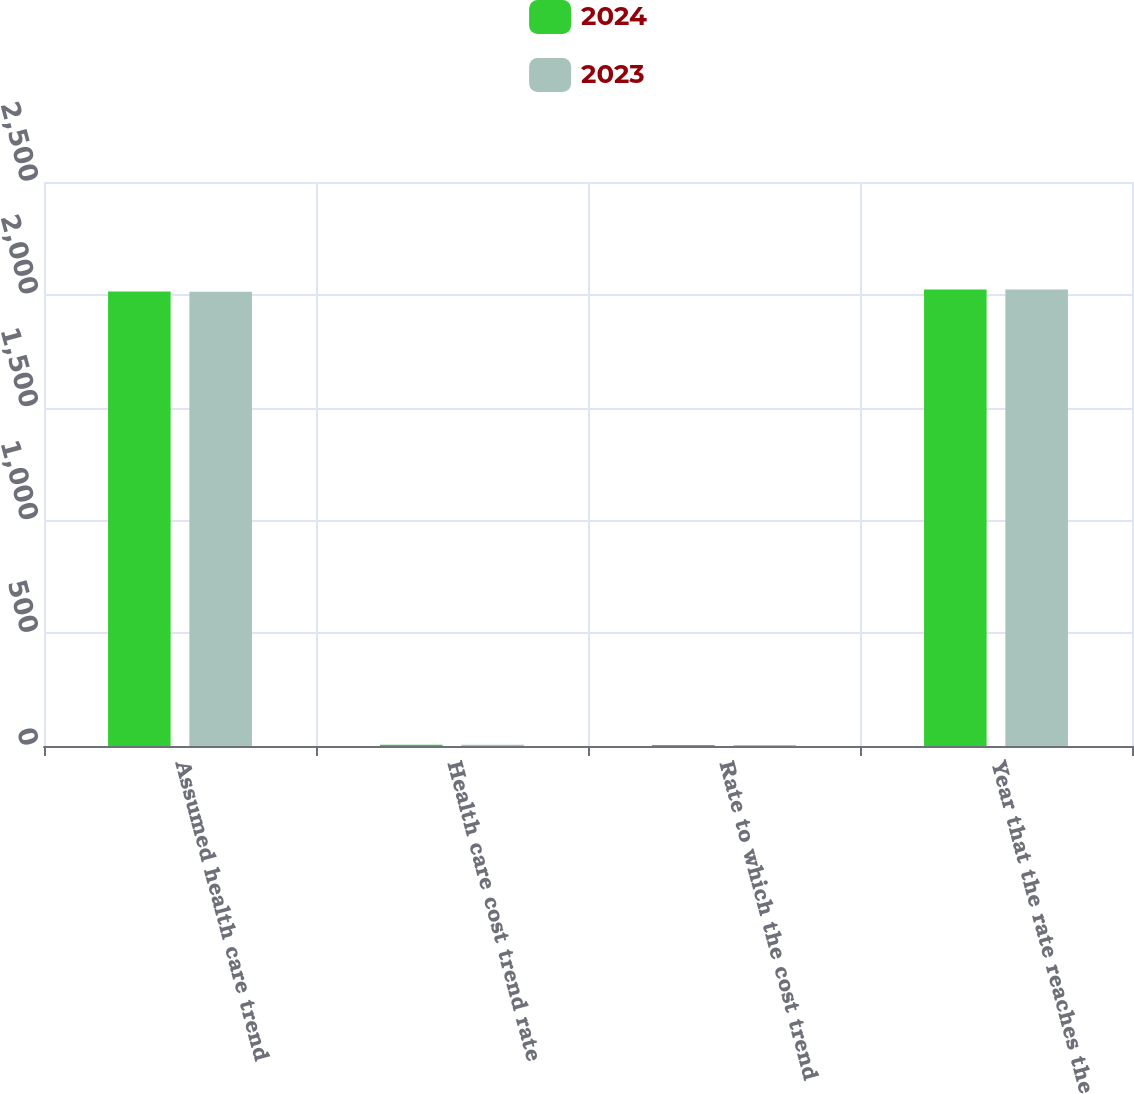<chart> <loc_0><loc_0><loc_500><loc_500><stacked_bar_chart><ecel><fcel>Assumed health care trend<fcel>Health care cost trend rate<fcel>Rate to which the cost trend<fcel>Year that the rate reaches the<nl><fcel>2024<fcel>2015<fcel>5.21<fcel>4.56<fcel>2024<nl><fcel>2023<fcel>2014<fcel>5.25<fcel>4.55<fcel>2023<nl></chart> 